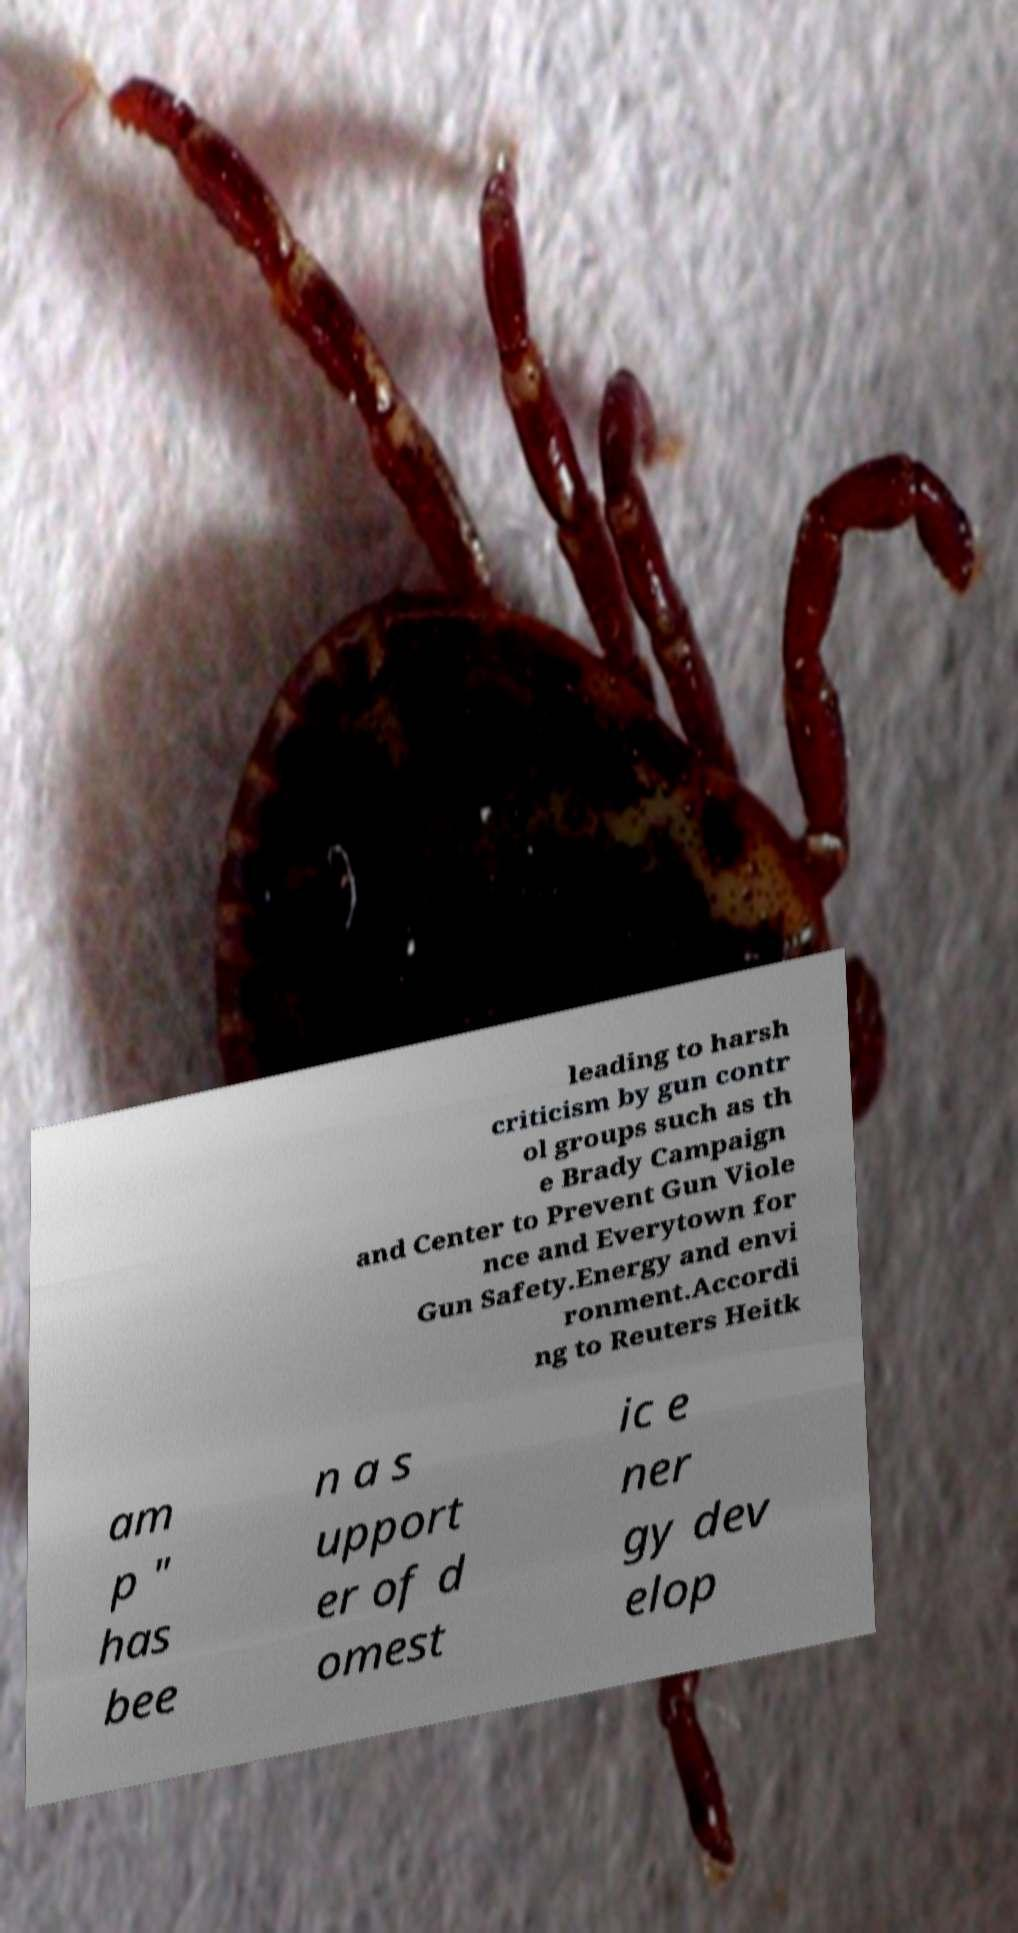Can you read and provide the text displayed in the image?This photo seems to have some interesting text. Can you extract and type it out for me? leading to harsh criticism by gun contr ol groups such as th e Brady Campaign and Center to Prevent Gun Viole nce and Everytown for Gun Safety.Energy and envi ronment.Accordi ng to Reuters Heitk am p " has bee n a s upport er of d omest ic e ner gy dev elop 